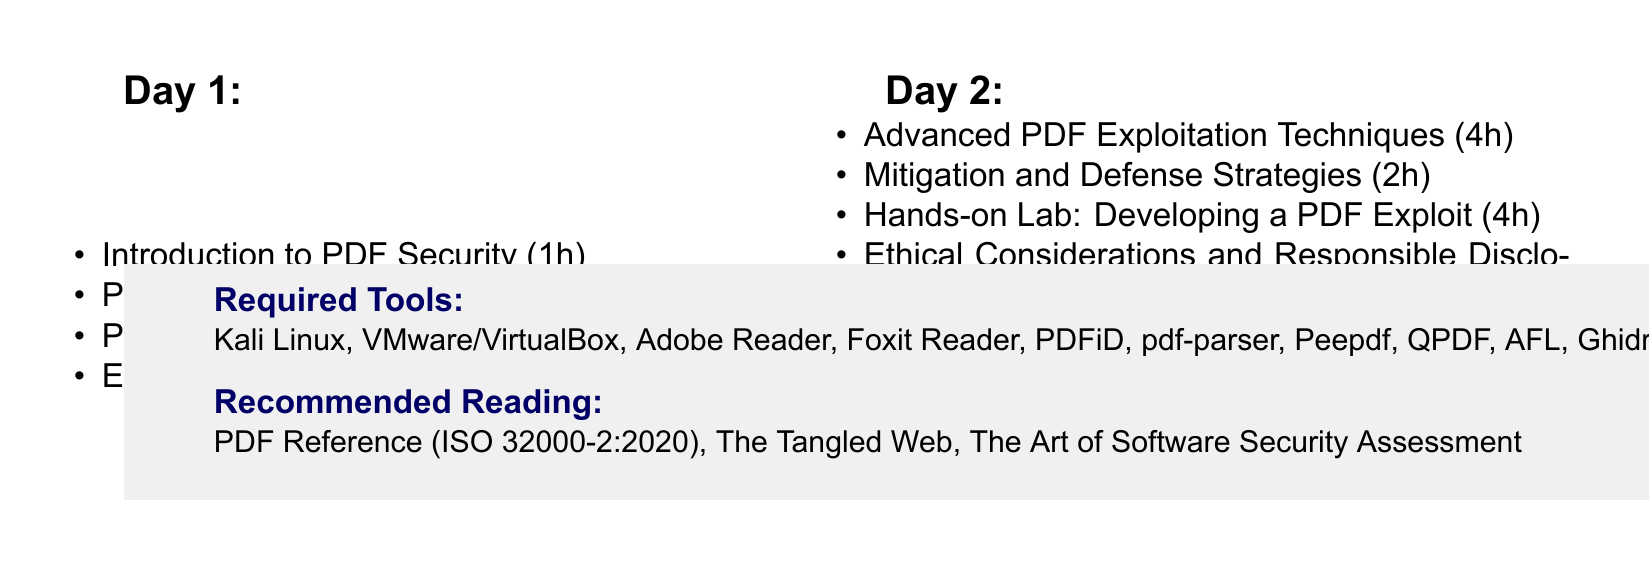What is the title of the workshop? The title of the workshop is explicitly mentioned at the beginning of the document.
Answer: Advanced PDF Exploitation: Uncovering Vulnerabilities in Document Processing Software How long is the workshop? The total duration of the workshop is specified in the document.
Answer: 2 days Who is the target audience for the workshop? The document lists the intended participants for the workshop.
Answer: Security researchers, penetration testers, and ethical hackers What is the duration of the "Exploiting JavaScript in PDFs" session? The duration of the session is explicitly stated in the agenda.
Answer: 4 hours Which tool is used for fuzzing PDF files? The document lists the tools needed for PDF analysis, including the specific tool for fuzzing.
Answer: American Fuzzy Lop (AFL) What is the focus of the "Advanced PDF Exploitation Techniques" session? The document describes the focus topics of this session within the agenda.
Answer: Heap spraying, ROP chains, format string vulnerabilities What are attendees expected to create during the hands-on lab? The document outlines the primary tasks outlined for the lab session.
Answer: A malicious PDF file How long is the session on Ethical Considerations? The document specifies the duration of this particular session in the agenda.
Answer: 1 hour What is one recommended reading from the document? The document provides a list of recommended readings related to the workshop content.
Answer: The PDF Reference (ISO 32000-2:2020) 